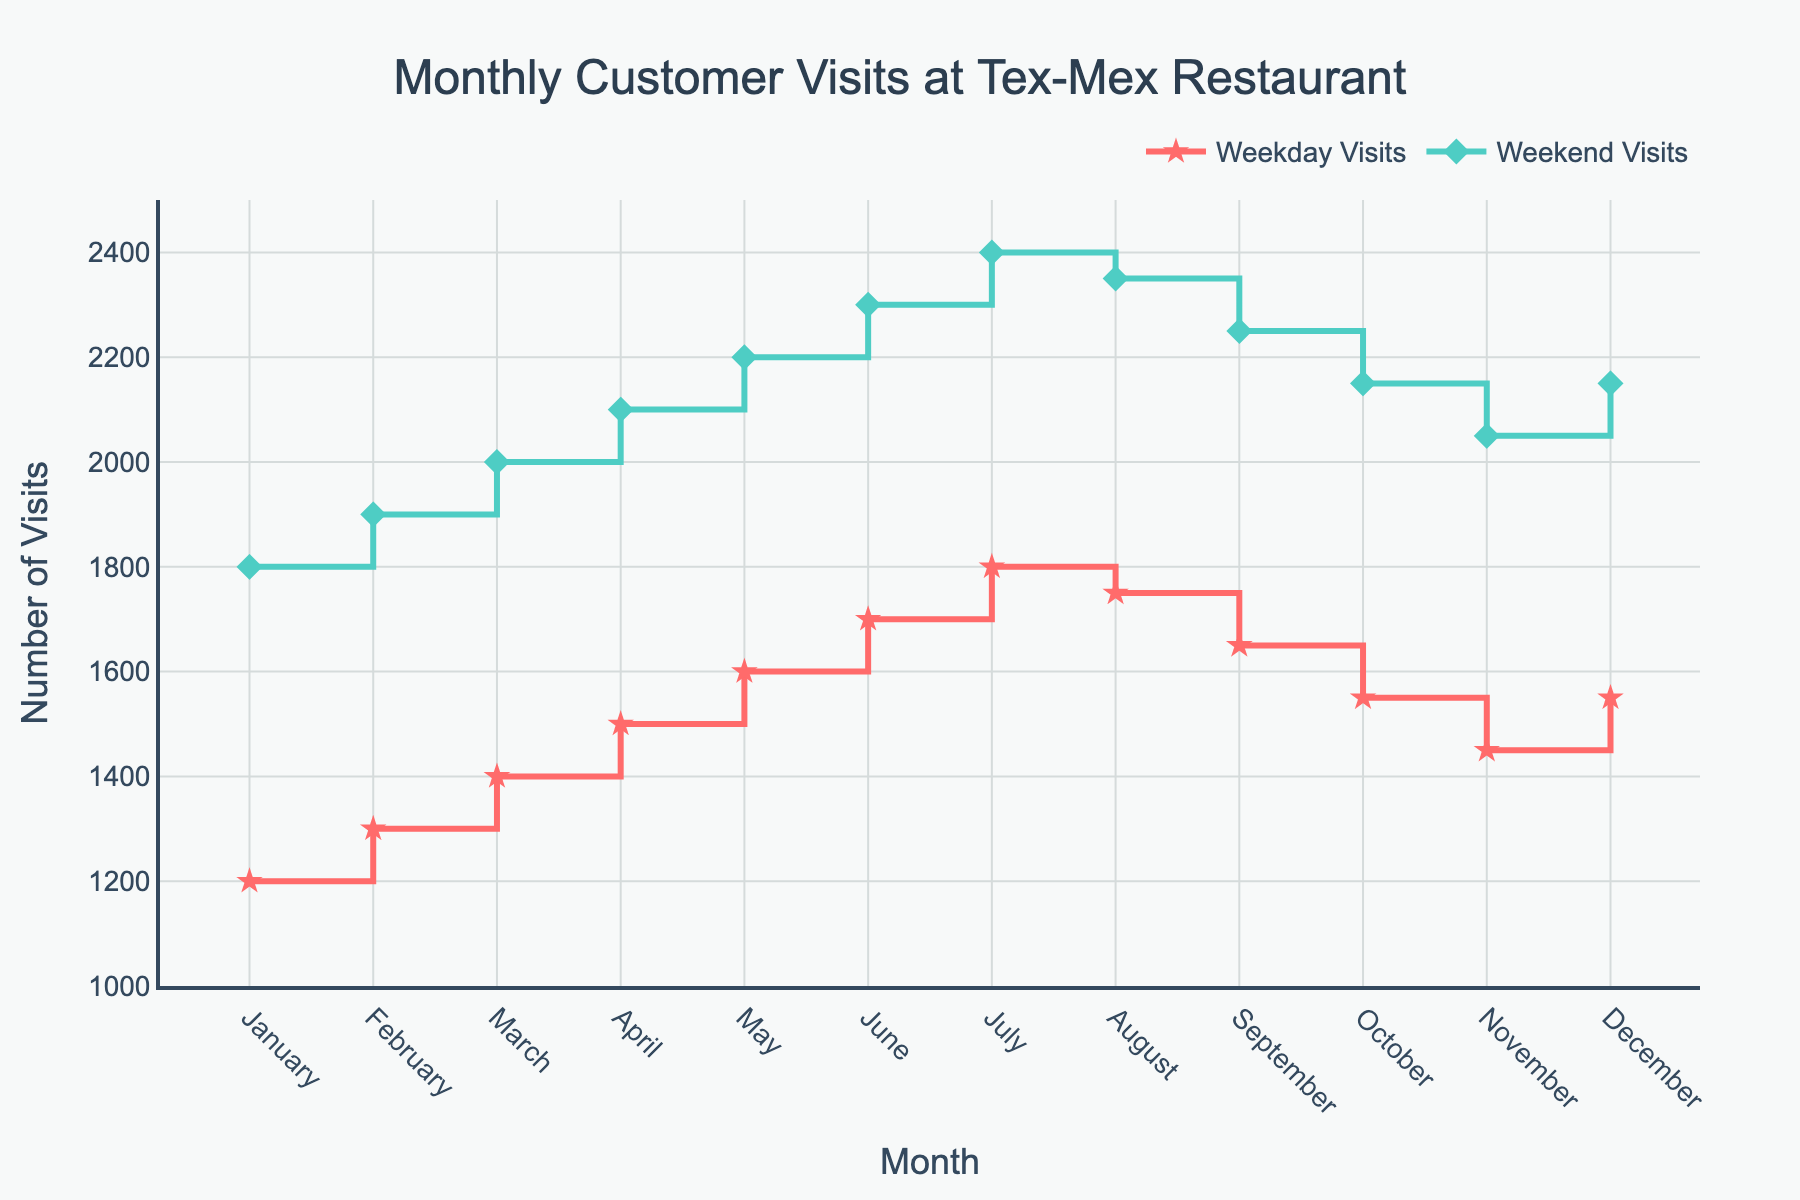How many total visits were there in March? Combine the weekday and weekend visits for March. Weekday Visits (1400) + Weekend Visits (2000) = 3400
Answer: 3400 Which month had the highest number of weekend visits? Look for the highest value in the Weekend Visits series. July had the highest with 2400 visits.
Answer: July In which month did weekday visits surpass 1700 for the first time? Observe the Weekday Visits series for the first month where the value exceeds 1700. June had 1700 visits, but July had 1800, thus July.
Answer: July What is the average number of weekend visits across the year? Sum of all Weekend Visits (1800+1900+2000+2100+2200+2300+2400+2350+2250+2150+2050+2150) = 25650, divided by 12 months, 25650/12 = 2137.5
Answer: 2137.5 Is there any month where weekday visits decreased compared to the previous month? Compare each month's weekday visits to the previous month using the Weekday Visits series. August (1750) decreased from July (1800).
Answer: Yes, August Which month had the smallest difference between weekday and weekend visits? Calculate the difference for each month and find the smallest difference. August had the smallest difference:
Answer: 600 (2350-1750) Do the weekends always have more visits than weekdays? Compare weekday and weekend values for each month. Each month, the Weekend Visits are higher than Weekday Visits.
Answer: Yes In which month do we see the largest increase in weekday visits from the previous month? Calculate the difference for each month and find the largest increase: from April to May, 1600 \- 1500 = 100 visits.
Answer: May During which month did the restaurant experience a peak in total visits, and what was that total? Determine the sum of weekday and weekend visits for each month and find the highest sum. July had the peak with 1800+2400 = 4200 visits.
Answer: July, 4200 Is there a seasonal trend observable in the customer visits? By looking at the monthly trends, observe a general increase in visits leading up to summer (July) and a decrease afterward till December.
Answer: Yes, with a peak in the mid-year (summer) 